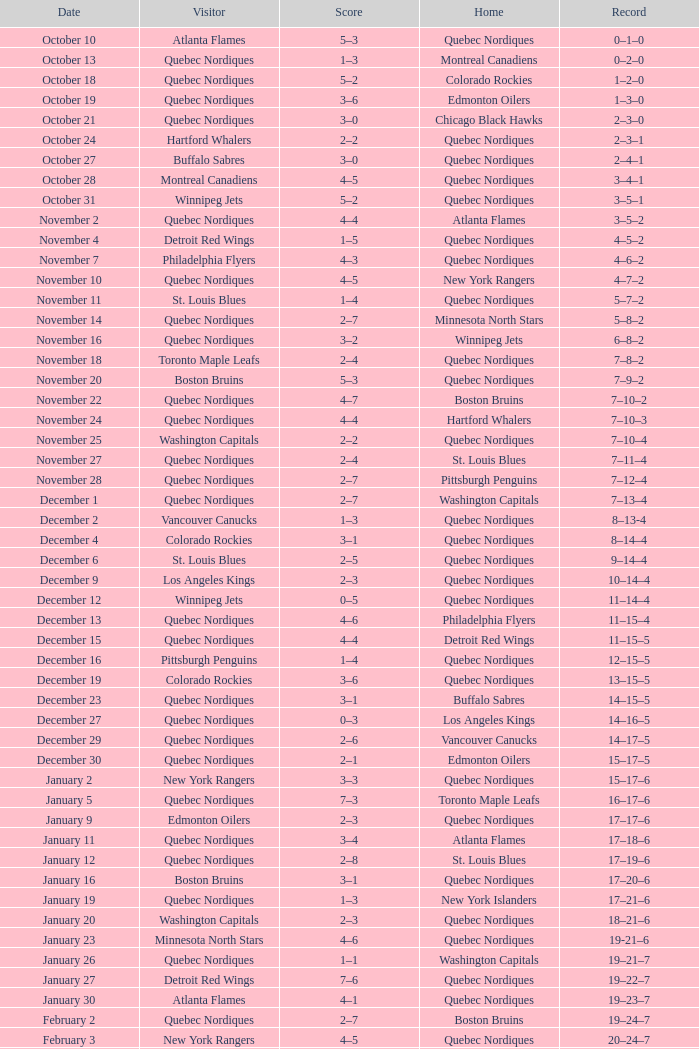Which Home has a Date of april 1? Quebec Nordiques. 